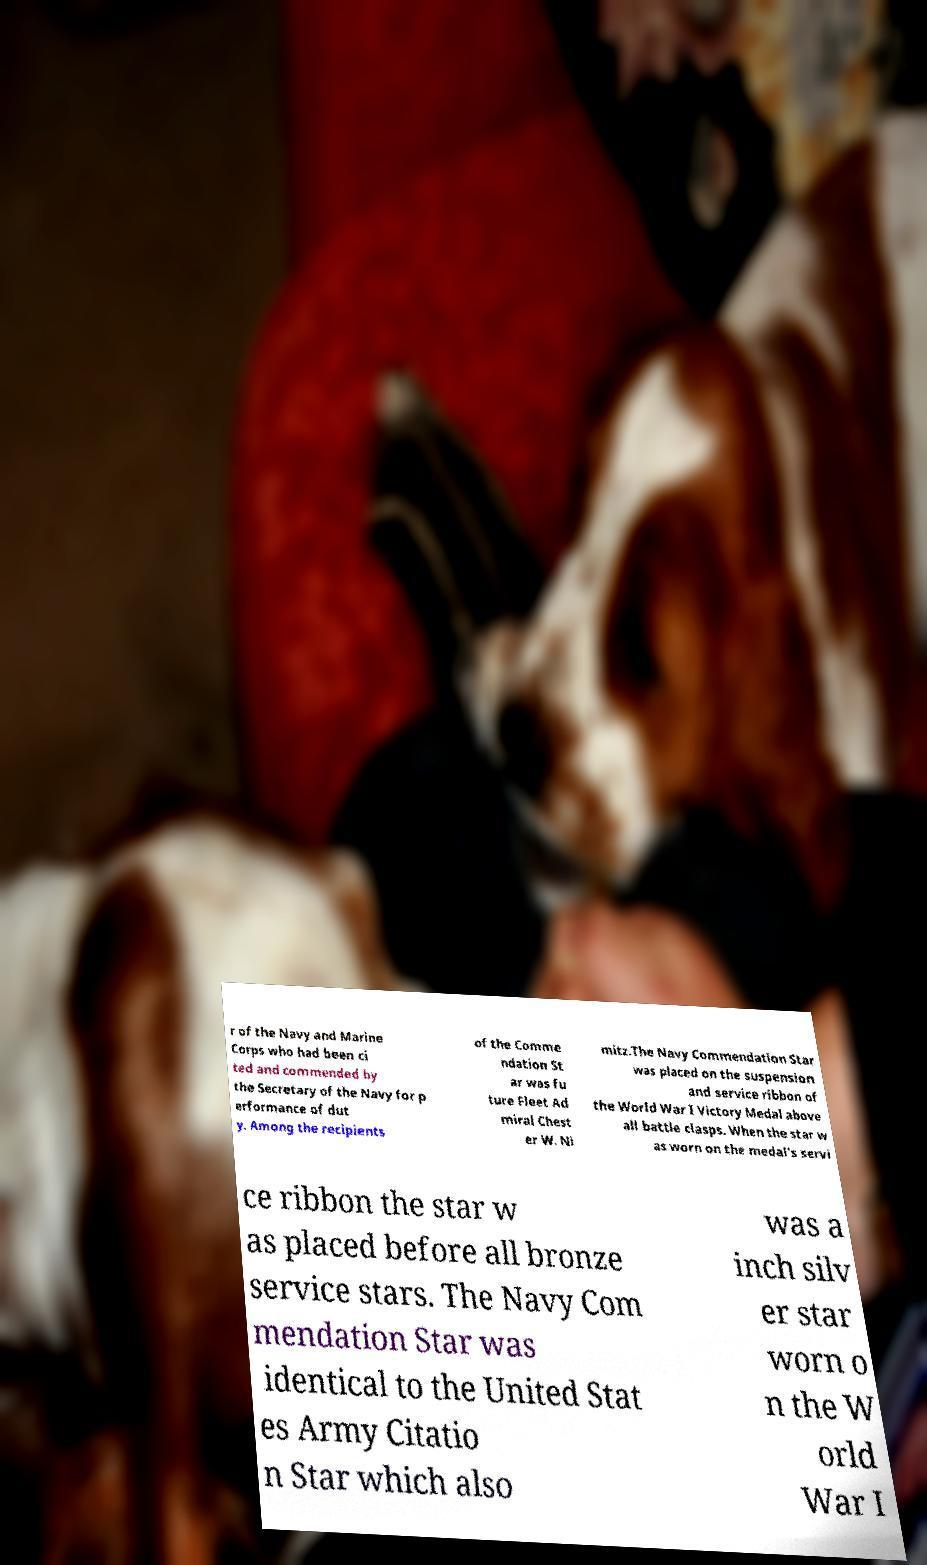Can you read and provide the text displayed in the image?This photo seems to have some interesting text. Can you extract and type it out for me? r of the Navy and Marine Corps who had been ci ted and commended by the Secretary of the Navy for p erformance of dut y. Among the recipients of the Comme ndation St ar was fu ture Fleet Ad miral Chest er W. Ni mitz.The Navy Commendation Star was placed on the suspension and service ribbon of the World War I Victory Medal above all battle clasps. When the star w as worn on the medal's servi ce ribbon the star w as placed before all bronze service stars. The Navy Com mendation Star was identical to the United Stat es Army Citatio n Star which also was a inch silv er star worn o n the W orld War I 